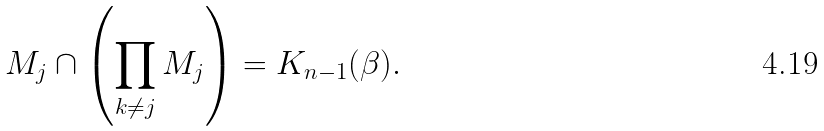<formula> <loc_0><loc_0><loc_500><loc_500>M _ { j } \cap \left ( \prod _ { k \neq j } M _ { j } \right ) = K _ { n - 1 } ( \beta ) .</formula> 